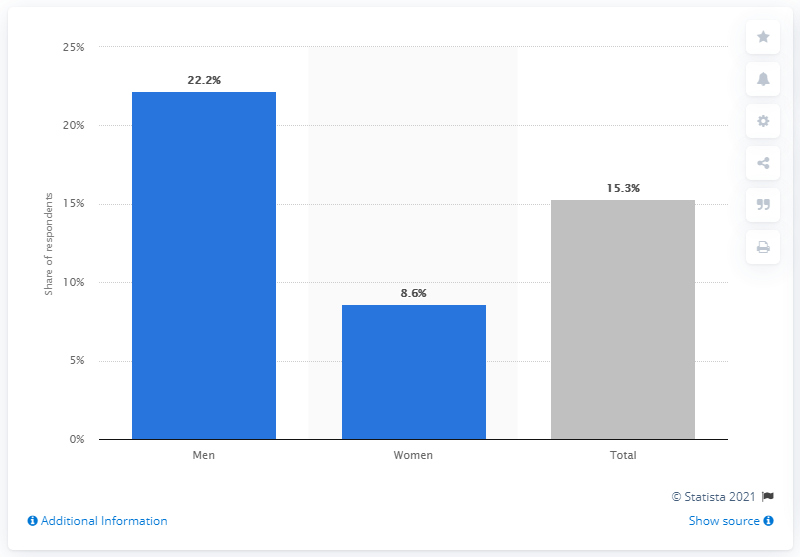What conclusions could we draw from this data about internet behavior? The data suggests that there is a gender difference in searching for sexual partners online. Men seem to use the internet for this purpose more than women, as indicated by the higher percentage depicted in the graph. It could reflect social, behavioral, and cultural factors influencing how different genders approach online dating and search for sexual partners. 